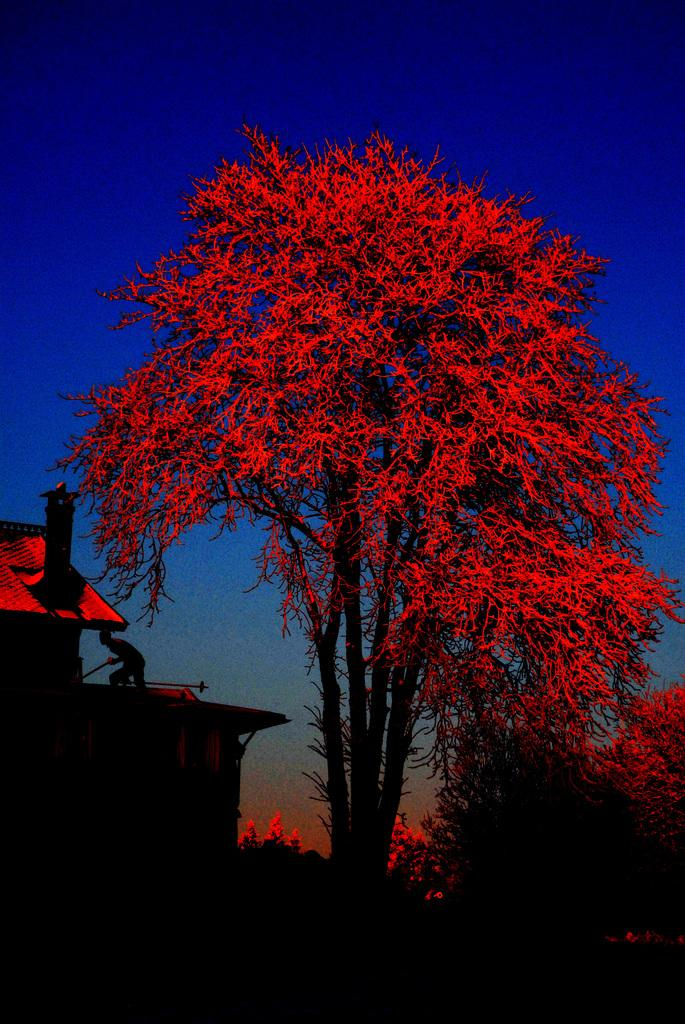What type of vegetation is on the right side of the image? There are trees on the right side of the image. What structure is located on the left side of the image? There is a house on the left side of the image. What is the person in the image doing? A person is standing on the house. What is visible at the top of the image? The sky is visible at the top of the image. What type of crown is the person wearing while standing on the house? There is no crown present in the image; the person is not wearing any headgear. What is the person's income while standing on the house? The image does not provide any information about the person's income. 